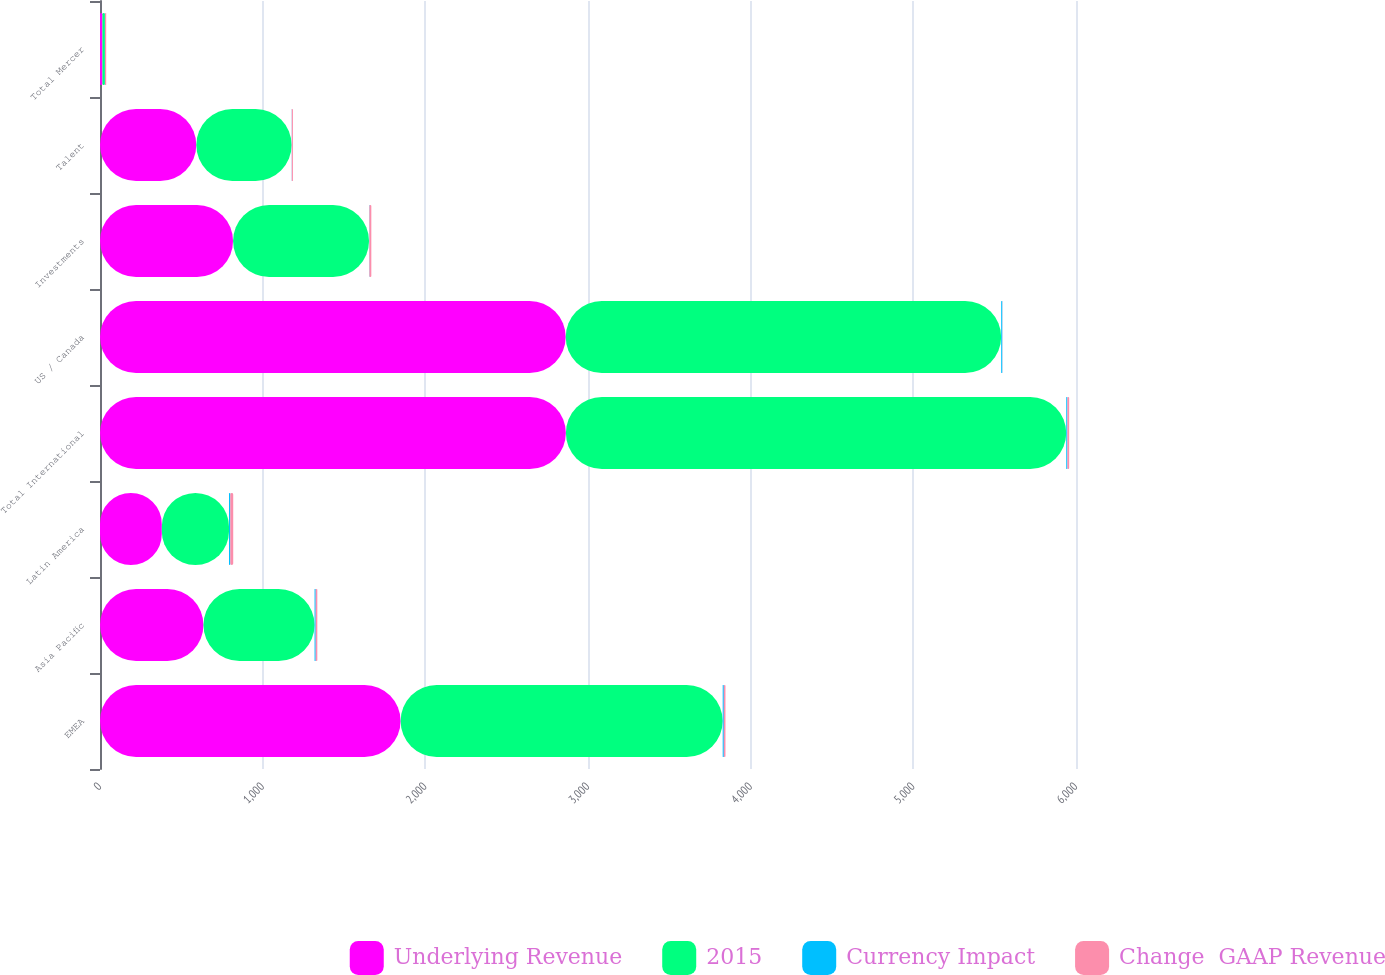Convert chart to OTSL. <chart><loc_0><loc_0><loc_500><loc_500><stacked_bar_chart><ecel><fcel>EMEA<fcel>Asia Pacific<fcel>Latin America<fcel>Total International<fcel>US / Canada<fcel>Investments<fcel>Talent<fcel>Total Mercer<nl><fcel>Underlying Revenue<fcel>1848<fcel>636<fcel>380<fcel>2864<fcel>2863<fcel>818<fcel>592<fcel>15<nl><fcel>2015<fcel>1980<fcel>683<fcel>413<fcel>3076<fcel>2677<fcel>836<fcel>586<fcel>15<nl><fcel>Currency Impact<fcel>7<fcel>7<fcel>8<fcel>7<fcel>7<fcel>2<fcel>1<fcel>1<nl><fcel>Change  GAAP Revenue<fcel>10<fcel>10<fcel>18<fcel>11<fcel>1<fcel>12<fcel>7<fcel>7<nl></chart> 